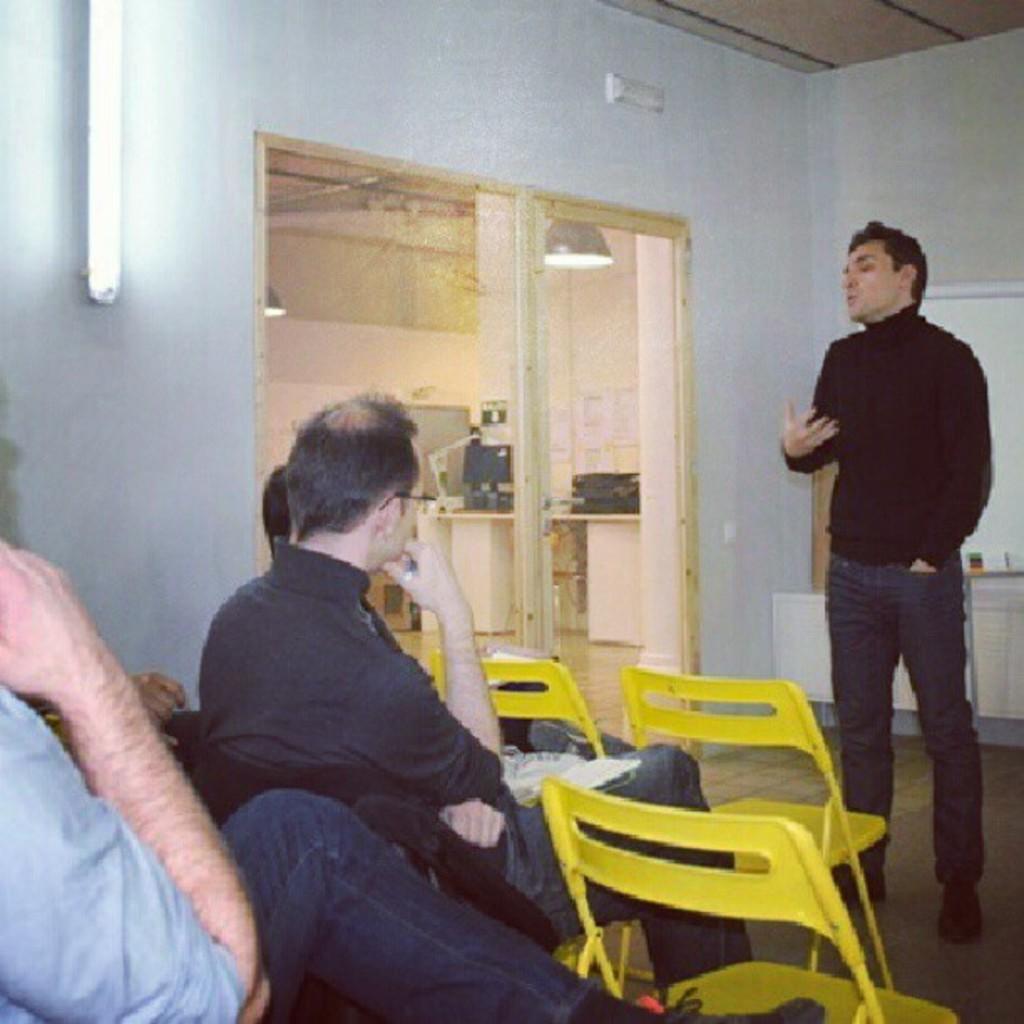Could you give a brief overview of what you see in this image? Few persons are sitting on the chairs and this person standing and talking. We can see chairs on the floor. On the background we can see wall,light,glass door,from this glass door we can see objects on the table,lights. 